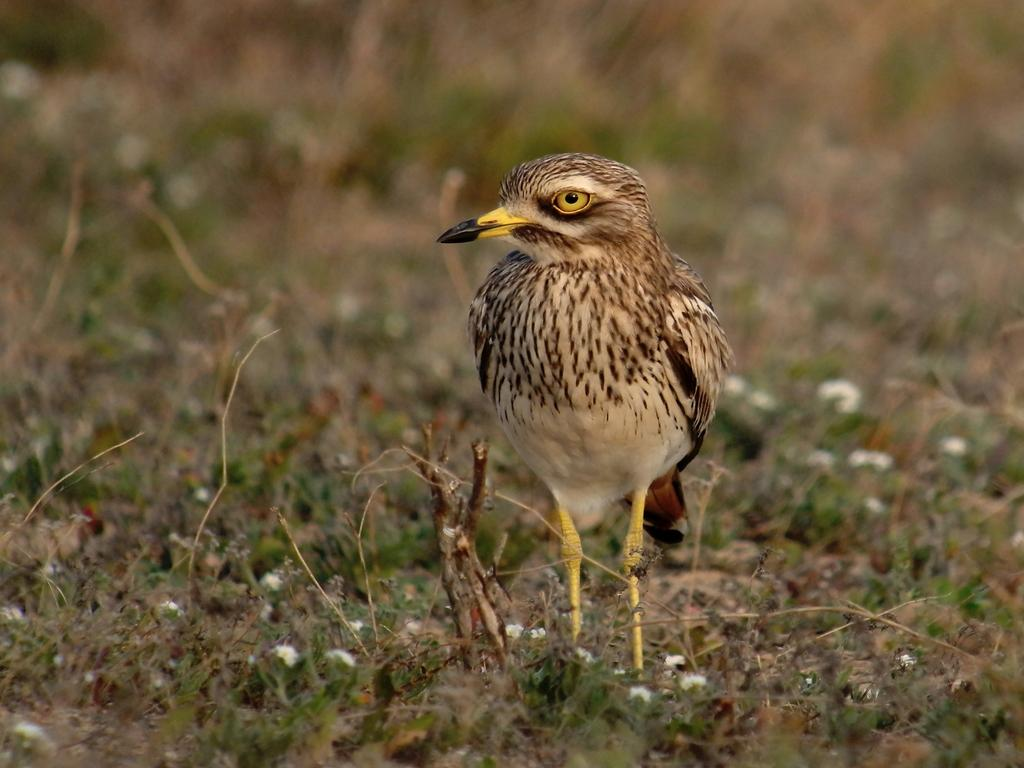What type of animal can be seen in the picture? There is a bird in the picture. What other elements are present at the bottom of the picture? There are small flowering plants at the bottom of the picture. What type of brass instrument is being played by the bird in the picture? There is no brass instrument or any indication of music in the picture; it features a bird and small flowering plants. 